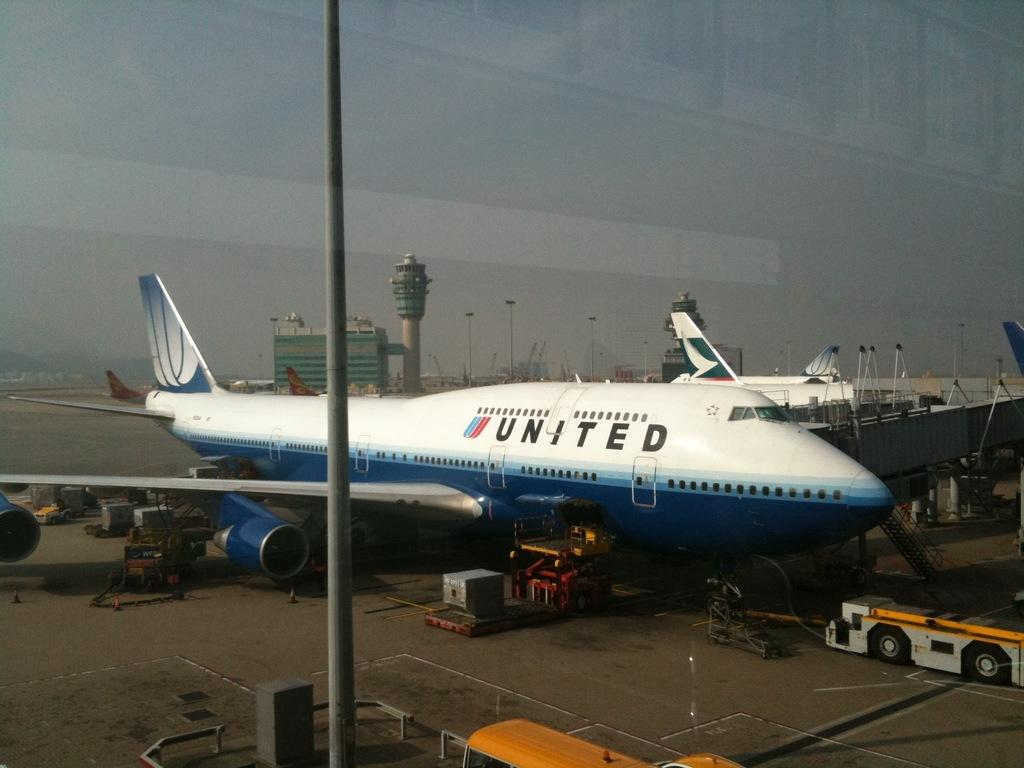<image>
Relay a brief, clear account of the picture shown. The blue and white plane at the airport has UNITED written on it. 